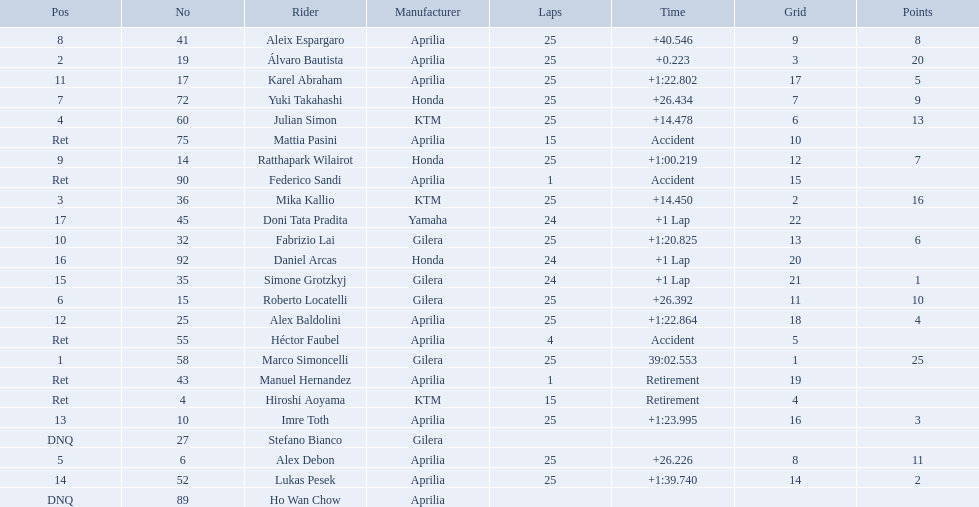How many laps did marco perform? 25. How many laps did hiroshi perform? 15. Which of these numbers are higher? 25. Who swam this number of laps? Marco Simoncelli. 